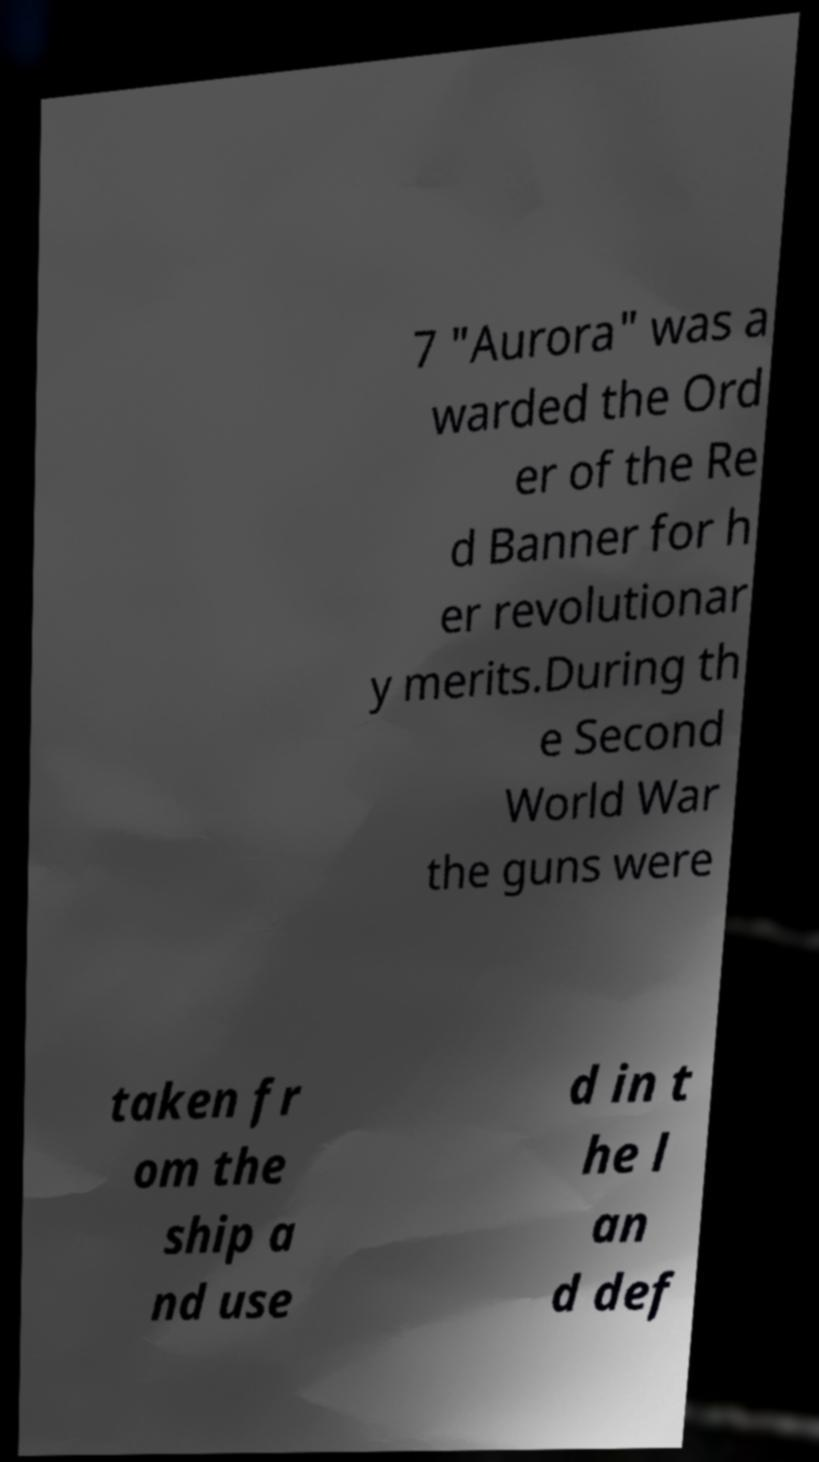Could you assist in decoding the text presented in this image and type it out clearly? 7 "Aurora" was a warded the Ord er of the Re d Banner for h er revolutionar y merits.During th e Second World War the guns were taken fr om the ship a nd use d in t he l an d def 